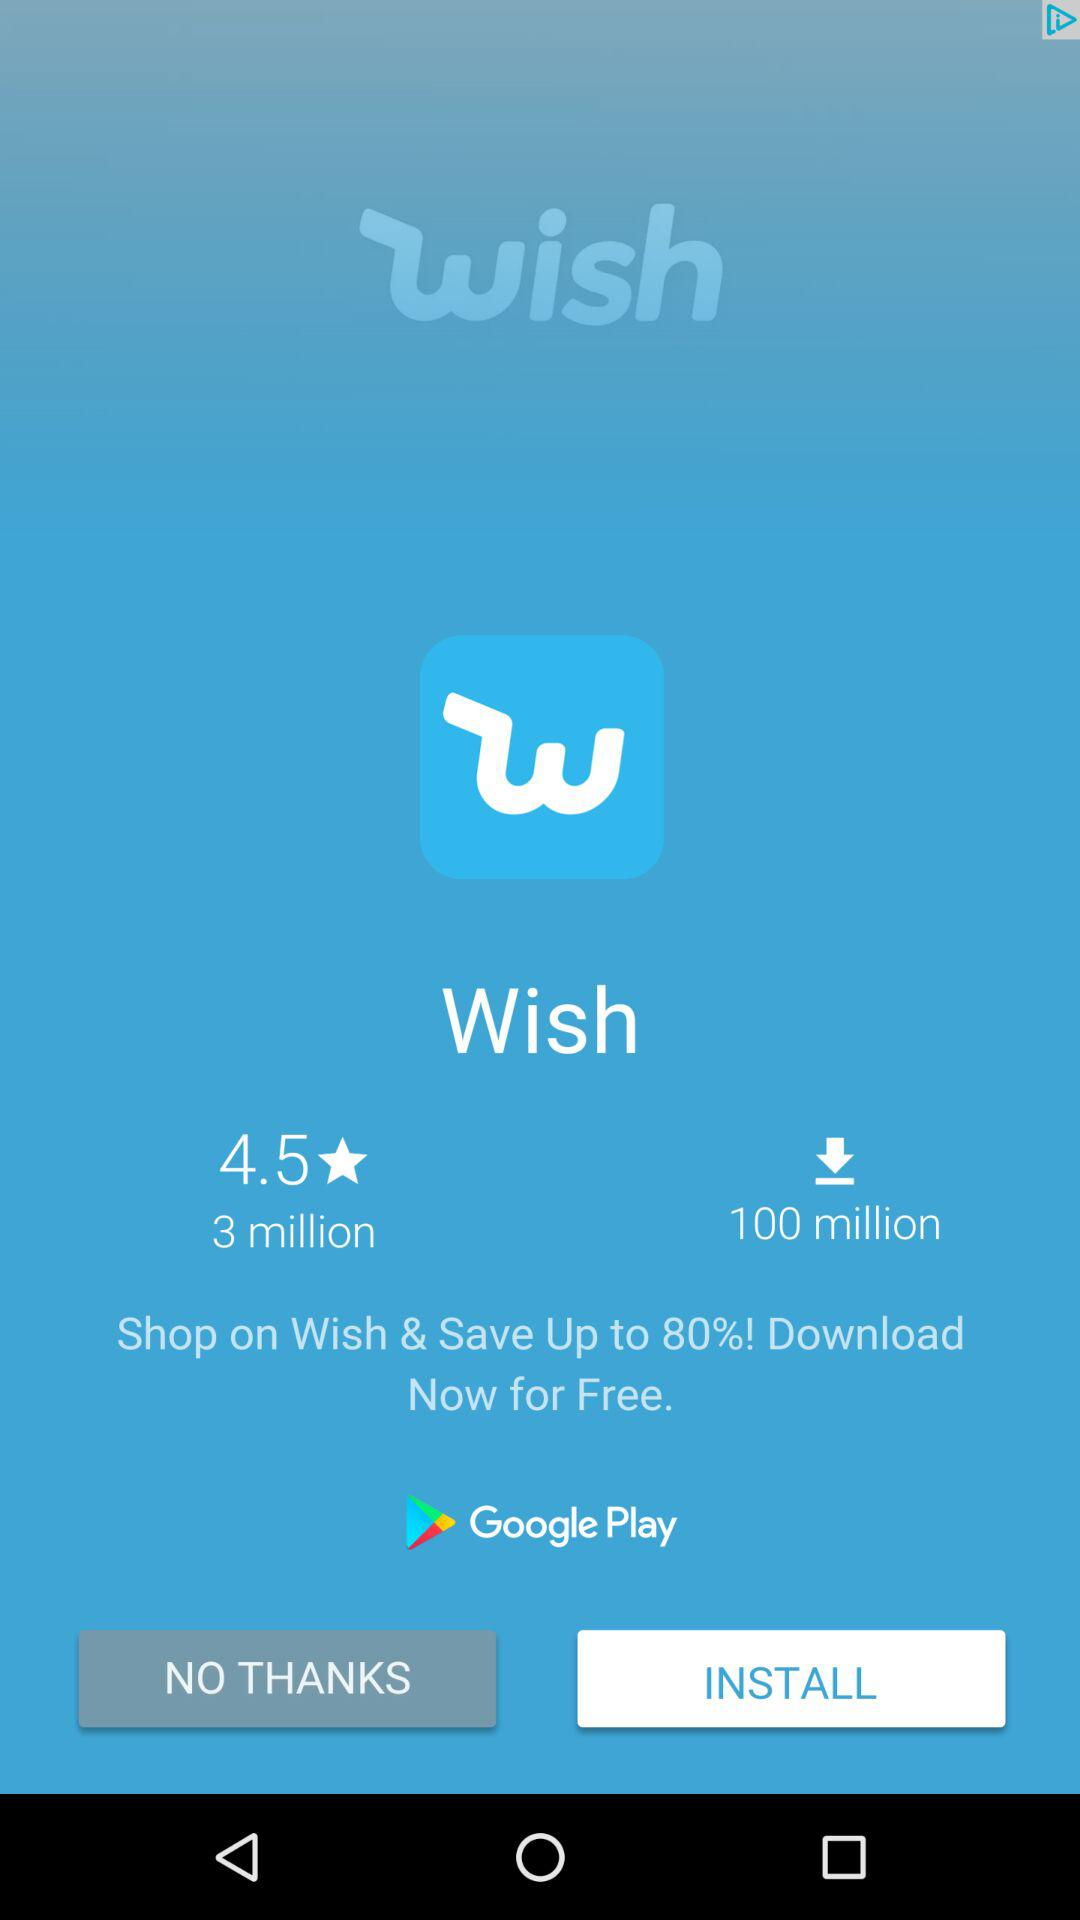How many more downloads does the app have than reviews?
Answer the question using a single word or phrase. 97 million 